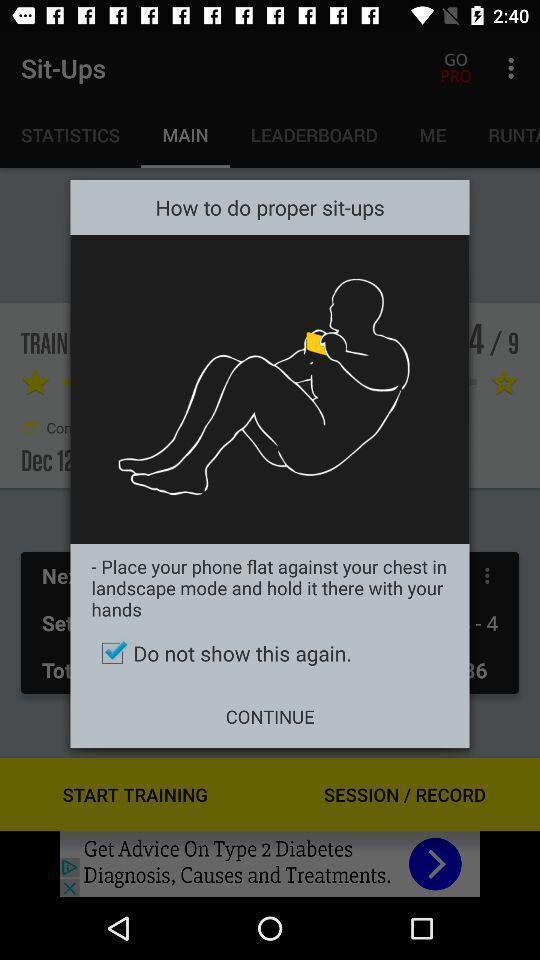What can you discern from this picture? Popup showing directions for an exercise. 